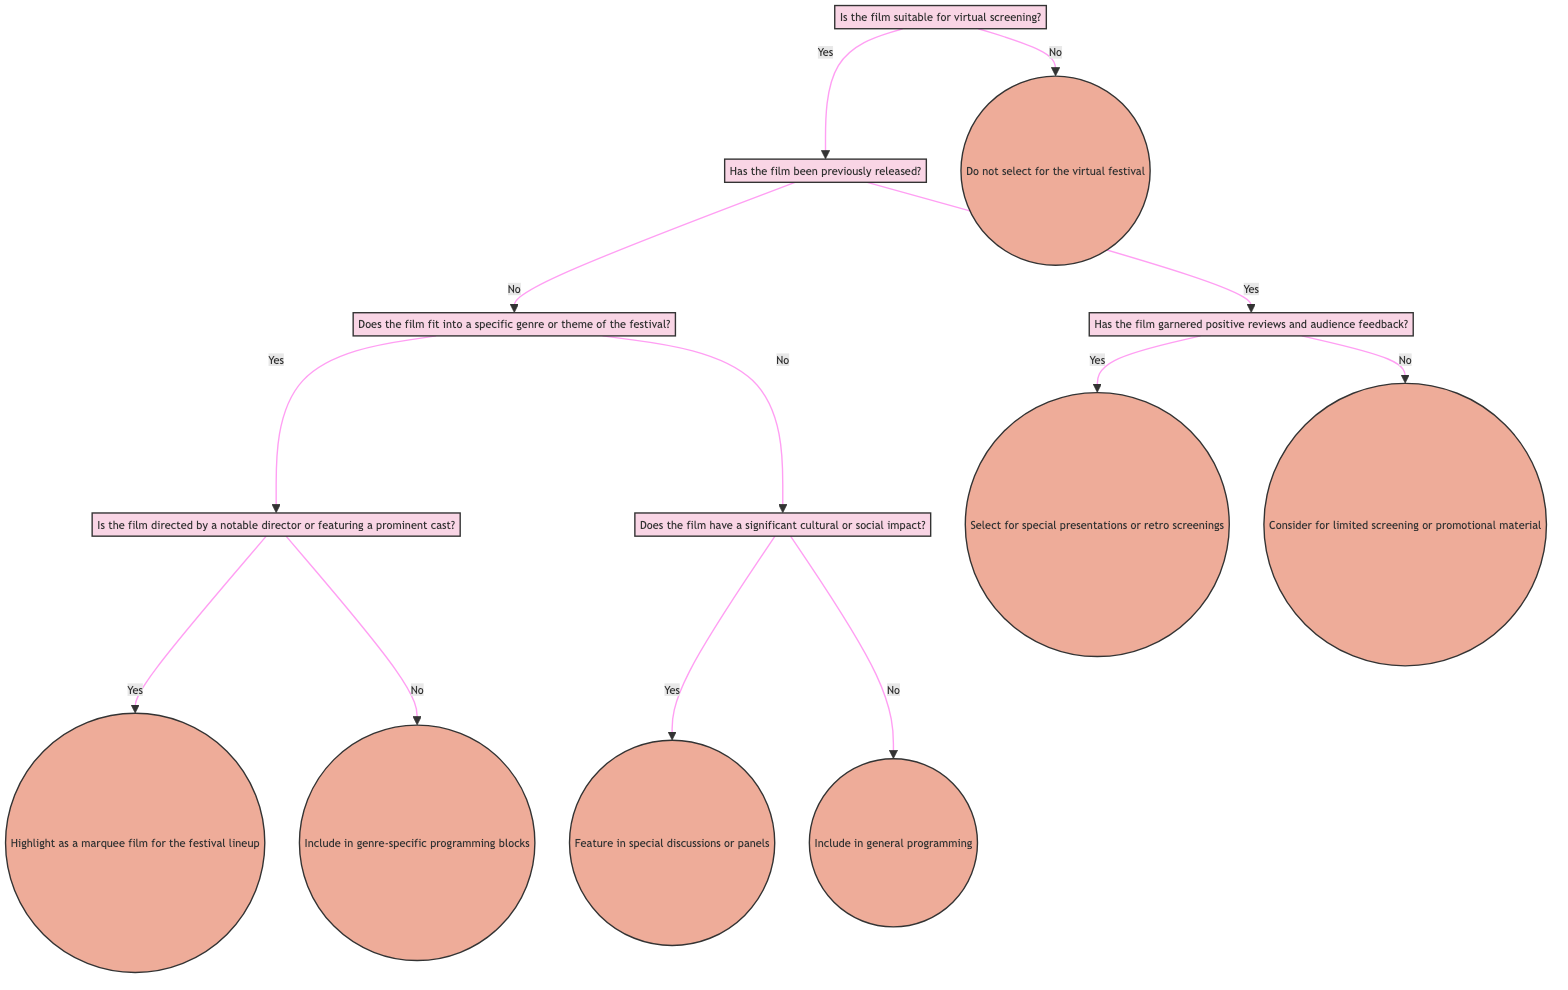What is the first decision node in the diagram? The first decision node is "Is the film suitable for virtual screening?" which sets the foundation for the subsequent decisions regarding film selection for the virtual festival.
Answer: Is the film suitable for virtual screening? How many action nodes are present in the diagram? The diagram has six action nodes: "Select for special presentations or retro screenings," "Consider for limited screening or promotional material," "Highlight as a marquee film for the festival lineup," "Include in genre-specific programming blocks," "Feature in special discussions or panels," and "Include in general programming." Counting these gives a total of six action nodes.
Answer: 6 What is the action taken if the film has been previously released but received negative reviews? If the film has been previously released and received negative reviews, the action taken is "Consider for limited screening or promotional material." This follows the decision path where the film is suitable for screening and previously released but has not garnered positive feedback.
Answer: Consider for limited screening or promotional material If the film is not suitable for virtual screening, what action is taken? The action taken if the film is not suitable for virtual screening is "Do not select for the virtual festival." This follows directly from the first decision node where the suitability of the film is assessed.
Answer: Do not select for the virtual festival What happens if the film does not fit into a specific genre or theme but has a significant cultural impact? If the film does not fit into a specific genre or theme but has significant cultural impact, it will be "Featured in special discussions or panels." This follows the decision path from assessing genre fit and directly evaluating cultural impact.
Answer: Feature in special discussions or panels What is the second decision node after confirming the film is suitable for screening? The second decision node after confirming the film's suitability for screening is "Has the film been previously released?" This step determines whether the film has prior exposure and informs further decisions based on its release status.
Answer: Has the film been previously released? What is one of the criteria for highlighting a film as a marquee film in the lineup? One of the criteria for highlighting a film as a marquee film is if "the film is directed by a notable director or featuring a prominent cast." This indicates that the film's pedigree can elevate its status in the festival lineup.
Answer: Is the film directed by a notable director or featuring a prominent cast? 